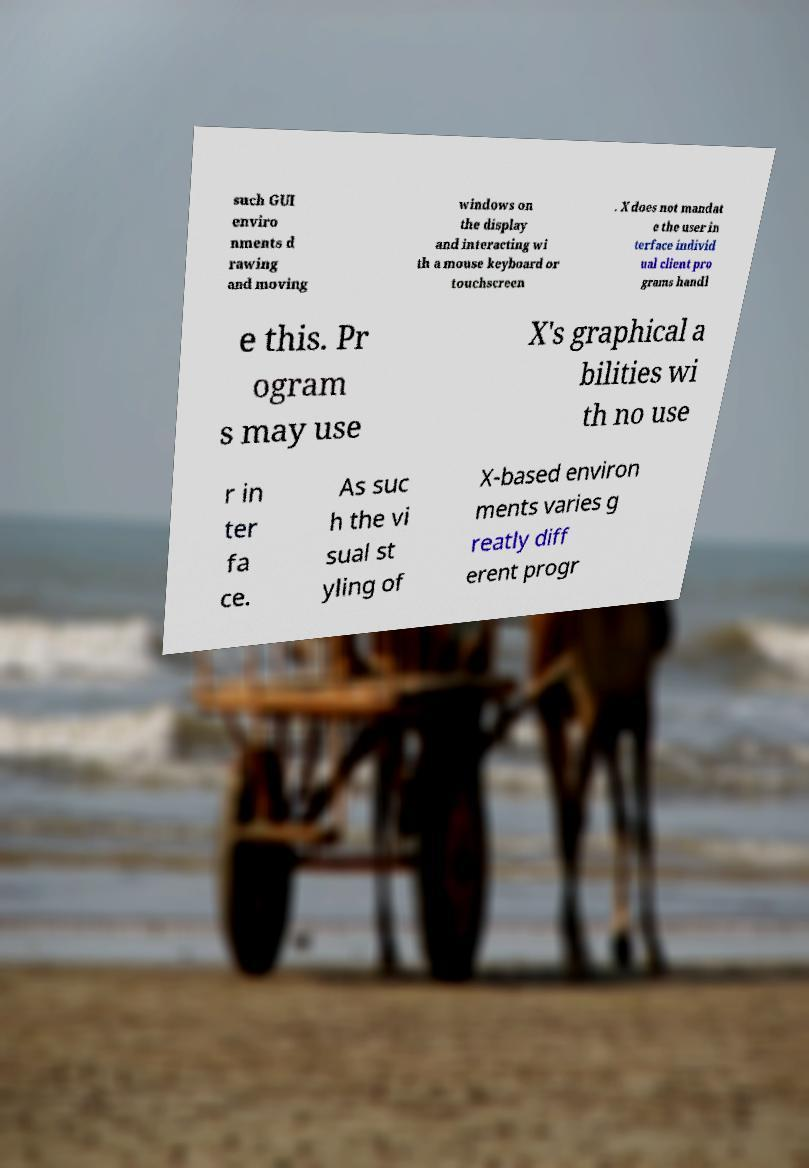Could you assist in decoding the text presented in this image and type it out clearly? such GUI enviro nments d rawing and moving windows on the display and interacting wi th a mouse keyboard or touchscreen . X does not mandat e the user in terface individ ual client pro grams handl e this. Pr ogram s may use X's graphical a bilities wi th no use r in ter fa ce. As suc h the vi sual st yling of X-based environ ments varies g reatly diff erent progr 